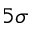Convert formula to latex. <formula><loc_0><loc_0><loc_500><loc_500>5 \sigma</formula> 